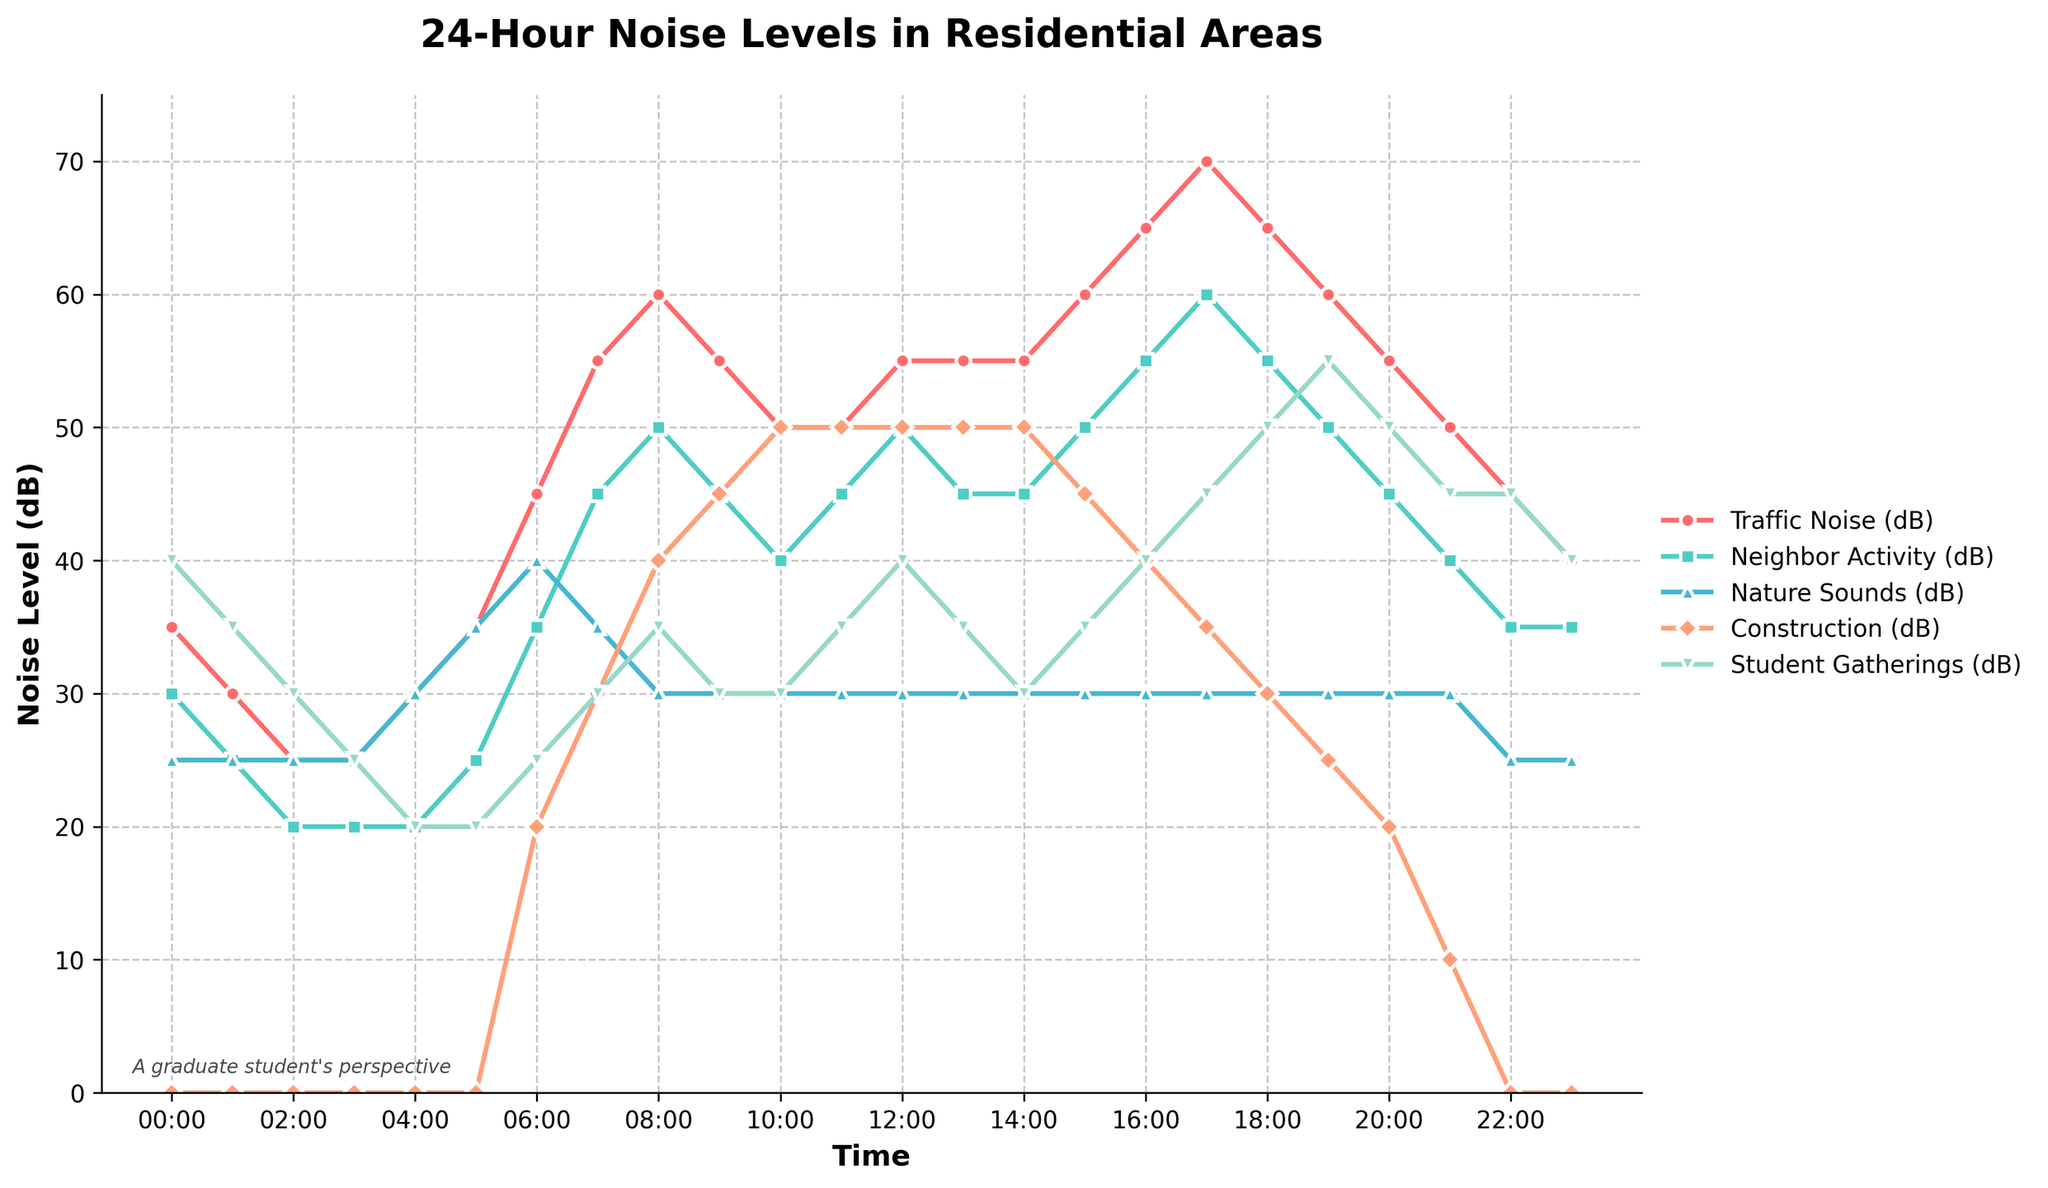What time of day does traffic noise reach its peak? Traffic noise is indicated by one of the lines in the chart, and the peak corresponds to the highest point on that line. Observing the traffic noise line, the highest value is at 17:00 with a level of 70 dB.
Answer: 17:00 Between 21:00 and 02:00, which source has the highest average noise level? The average noise level for each source during the specified time range can be calculated. The data points are as follows: 
21:00 - Student Gatherings (45), Construction (0), Nature Sounds (30), Neighbor Activity (40), Traffic Noise (50)
22:00 - Student Gatherings (45), Construction (0), Nature Sounds (25), Neighbor Activity (35), Traffic Noise (45)
23:00 - Student Gatherings (40), Construction (0), Nature Sounds (25), Neighbor Activity (35), Traffic Noise (40)
00:00 - Student Gatherings (40), Construction (0), Nature Sounds (25), Neighbor Activity (30), Traffic Noise (35)
01:00 - Student Gatherings (35), Construction (0), Nature Sounds (25), Neighbor Activity (25), Traffic Noise (30)
02:00 - Student Gatherings (30), Construction (0), Nature Sounds (25), Neighbor Activity (20), Traffic Noise (25)
Averaging the noise levels for Student Gatherings: (45+45+40+40+35+30)/6 = 235/6 ≈ 39.17 dB, which is the highest average among the sources.
Answer: Student Gatherings Which noise source is predominantly highest during the early morning hours (04:00 to 06:00)? Observing the values of the different noise sources during 04:00, 05:00, and 06:00, we can see which source has the greatest values during these hours:
04:00 - Nature Sounds (30)
05:00 - Nature Sounds (35)
06:00 - Nature Sounds (40)
Nature Sounds consistently have the highest values during the specified interval.
Answer: Nature Sounds Compare the noise levels of construction at 06:00 and 14:00, which is higher? The noise levels for construction at the specified times are 20 dB at 06:00 and 50 dB at 14:00. Clearly, the noise level at 14:00 is higher than at 06:00.
Answer: 14:00 What source contributes the least to noise after midnight (12:00 AM to 6:00 AM)? Evaluating the levels of different sources from 00:00 to 06:00 we get:
Traffic Noise (35, 30, 25, 25, 30, 35)
Neighbor Activity (30, 25, 20, 20, 20, 25)
Nature Sounds (25, 25, 25, 25, 30, 35)
Construction (0, 0, 0, 0, 0, 20)
Student Gatherings (40, 35, 30, 25, 20, 20)
Construction consistently shows the lowest values, with 0 dB till 05:00 AM and 20 dB at 06:00 AM.
Answer: Construction 